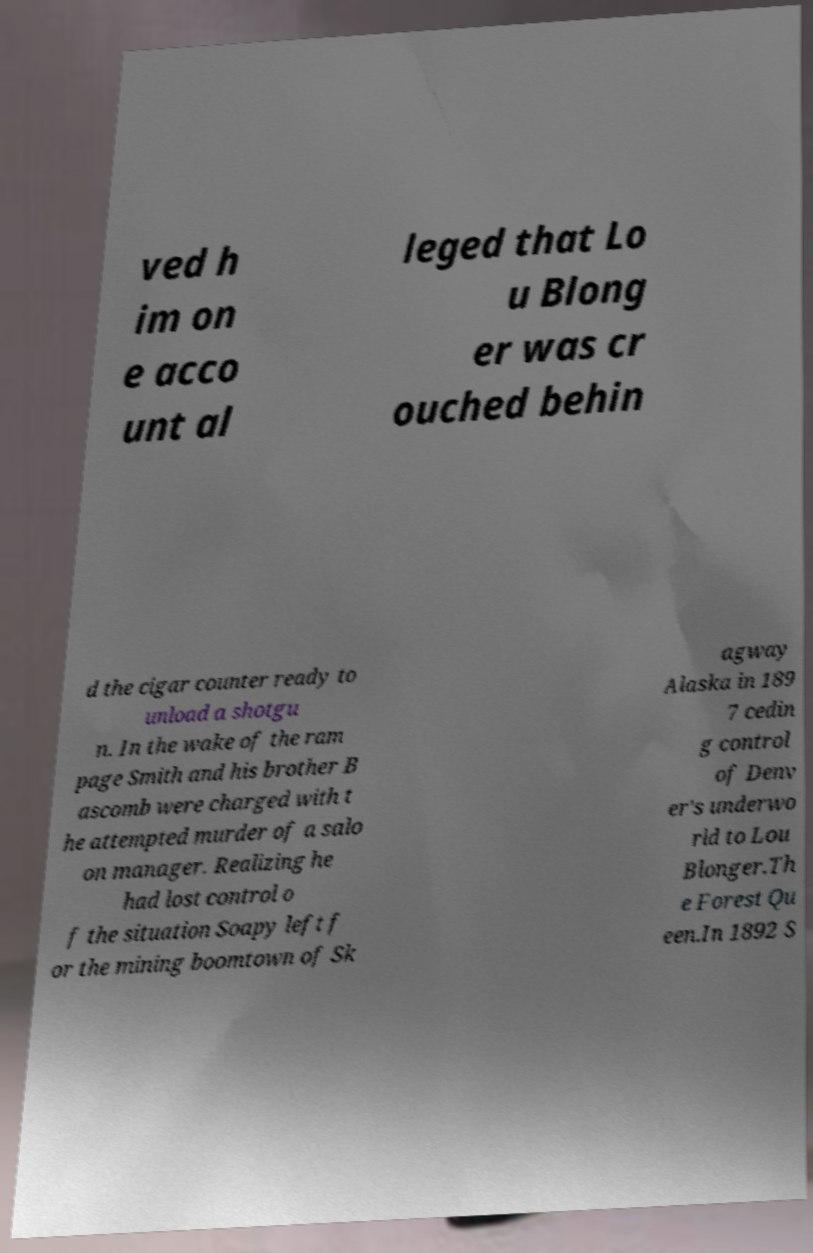Can you accurately transcribe the text from the provided image for me? ved h im on e acco unt al leged that Lo u Blong er was cr ouched behin d the cigar counter ready to unload a shotgu n. In the wake of the ram page Smith and his brother B ascomb were charged with t he attempted murder of a salo on manager. Realizing he had lost control o f the situation Soapy left f or the mining boomtown of Sk agway Alaska in 189 7 cedin g control of Denv er's underwo rld to Lou Blonger.Th e Forest Qu een.In 1892 S 